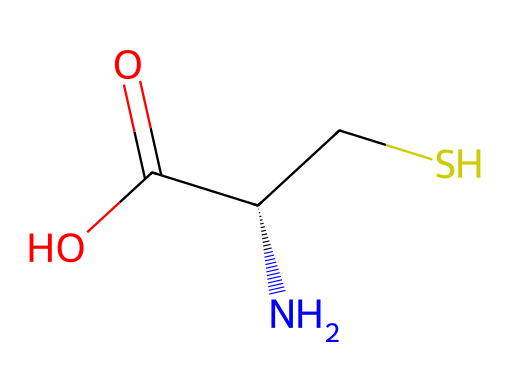What is the name of the compound represented by this SMILES? The SMILES notation indicates a compound containing an amino group (N), a carboxylic group (C(=O)O), and a thiol (CS). This corresponds to cysteine, which is an amino acid.
Answer: cysteine How many carbon atoms are in the structure? By examining the SMILES, we see one carbon in the thiol (CS) and another carbon in the backbone (N[C@@H]). Thus, there are two carbon atoms.
Answer: two What functional group is present in cysteine? The SMILES shows a thiol group (CS), which is a characteristic functional group for cysteine.
Answer: thiol What is the stereochemistry at the chiral center? The SMILES notation indicates an "@" symbol next to the chiral carbon (C) which denotes the presence of stereocenters, specifically here the configuration is S.
Answer: S What type of bond connects the sulfur and the carbon in the thiol group? The bond between the sulfur and carbon in the thiol group is a single covalent bond, which is evident from the structure depicted in the SMILES.
Answer: single covalent bond How many hydrogen atoms are present in cysteine? From the structure, by counting hydrogen bonded to the amino group (two H) and one from the thiol group and one attached to the backbone carbon, we find that there are broadly three hydrogen atoms.
Answer: three 